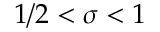Convert formula to latex. <formula><loc_0><loc_0><loc_500><loc_500>1 / 2 < \sigma < 1</formula> 